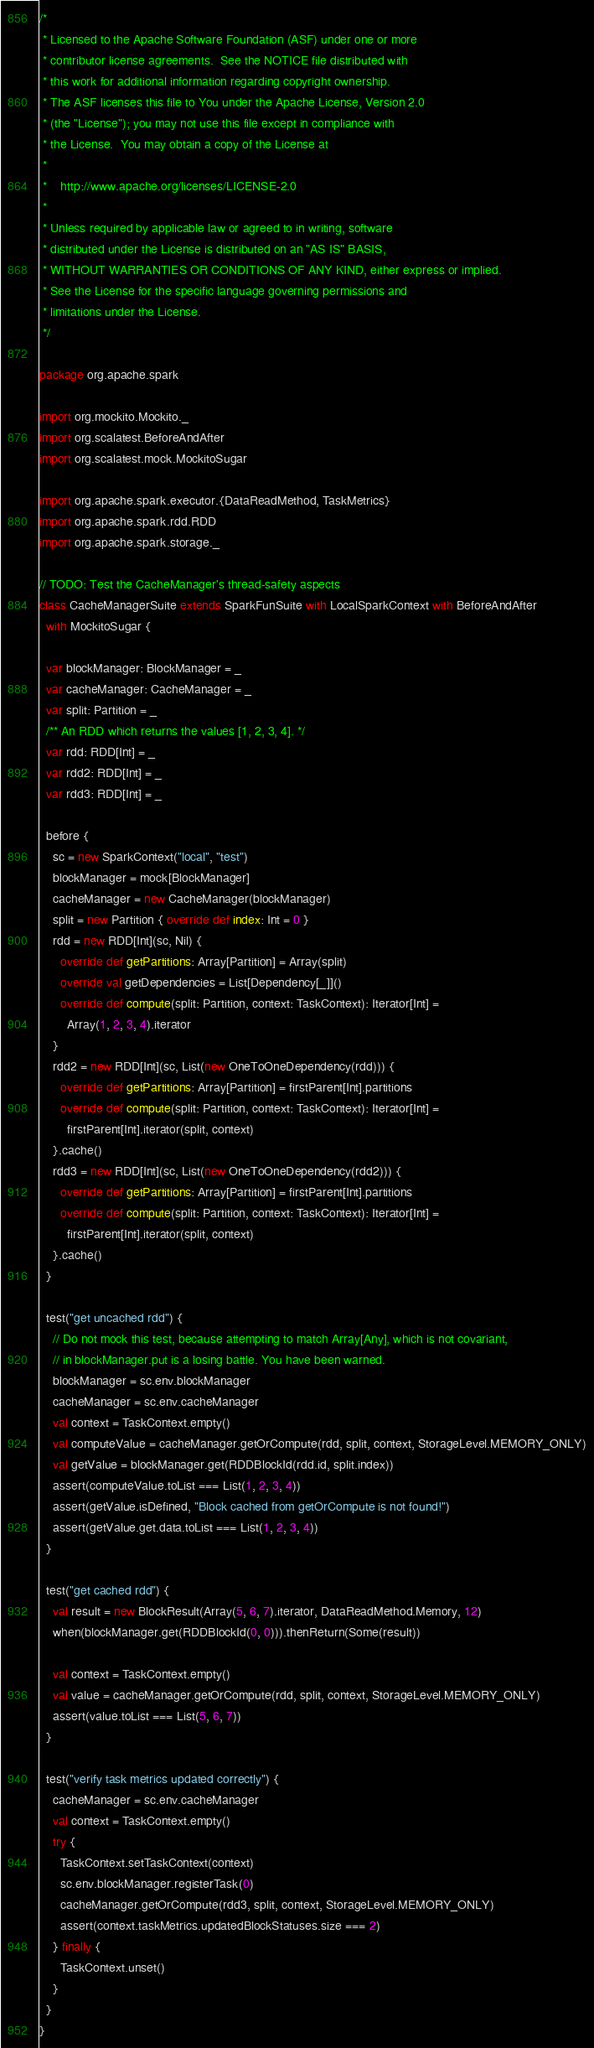<code> <loc_0><loc_0><loc_500><loc_500><_Scala_>/*
 * Licensed to the Apache Software Foundation (ASF) under one or more
 * contributor license agreements.  See the NOTICE file distributed with
 * this work for additional information regarding copyright ownership.
 * The ASF licenses this file to You under the Apache License, Version 2.0
 * (the "License"); you may not use this file except in compliance with
 * the License.  You may obtain a copy of the License at
 *
 *    http://www.apache.org/licenses/LICENSE-2.0
 *
 * Unless required by applicable law or agreed to in writing, software
 * distributed under the License is distributed on an "AS IS" BASIS,
 * WITHOUT WARRANTIES OR CONDITIONS OF ANY KIND, either express or implied.
 * See the License for the specific language governing permissions and
 * limitations under the License.
 */

package org.apache.spark

import org.mockito.Mockito._
import org.scalatest.BeforeAndAfter
import org.scalatest.mock.MockitoSugar

import org.apache.spark.executor.{DataReadMethod, TaskMetrics}
import org.apache.spark.rdd.RDD
import org.apache.spark.storage._

// TODO: Test the CacheManager's thread-safety aspects
class CacheManagerSuite extends SparkFunSuite with LocalSparkContext with BeforeAndAfter
  with MockitoSugar {

  var blockManager: BlockManager = _
  var cacheManager: CacheManager = _
  var split: Partition = _
  /** An RDD which returns the values [1, 2, 3, 4]. */
  var rdd: RDD[Int] = _
  var rdd2: RDD[Int] = _
  var rdd3: RDD[Int] = _

  before {
    sc = new SparkContext("local", "test")
    blockManager = mock[BlockManager]
    cacheManager = new CacheManager(blockManager)
    split = new Partition { override def index: Int = 0 }
    rdd = new RDD[Int](sc, Nil) {
      override def getPartitions: Array[Partition] = Array(split)
      override val getDependencies = List[Dependency[_]]()
      override def compute(split: Partition, context: TaskContext): Iterator[Int] =
        Array(1, 2, 3, 4).iterator
    }
    rdd2 = new RDD[Int](sc, List(new OneToOneDependency(rdd))) {
      override def getPartitions: Array[Partition] = firstParent[Int].partitions
      override def compute(split: Partition, context: TaskContext): Iterator[Int] =
        firstParent[Int].iterator(split, context)
    }.cache()
    rdd3 = new RDD[Int](sc, List(new OneToOneDependency(rdd2))) {
      override def getPartitions: Array[Partition] = firstParent[Int].partitions
      override def compute(split: Partition, context: TaskContext): Iterator[Int] =
        firstParent[Int].iterator(split, context)
    }.cache()
  }

  test("get uncached rdd") {
    // Do not mock this test, because attempting to match Array[Any], which is not covariant,
    // in blockManager.put is a losing battle. You have been warned.
    blockManager = sc.env.blockManager
    cacheManager = sc.env.cacheManager
    val context = TaskContext.empty()
    val computeValue = cacheManager.getOrCompute(rdd, split, context, StorageLevel.MEMORY_ONLY)
    val getValue = blockManager.get(RDDBlockId(rdd.id, split.index))
    assert(computeValue.toList === List(1, 2, 3, 4))
    assert(getValue.isDefined, "Block cached from getOrCompute is not found!")
    assert(getValue.get.data.toList === List(1, 2, 3, 4))
  }

  test("get cached rdd") {
    val result = new BlockResult(Array(5, 6, 7).iterator, DataReadMethod.Memory, 12)
    when(blockManager.get(RDDBlockId(0, 0))).thenReturn(Some(result))

    val context = TaskContext.empty()
    val value = cacheManager.getOrCompute(rdd, split, context, StorageLevel.MEMORY_ONLY)
    assert(value.toList === List(5, 6, 7))
  }

  test("verify task metrics updated correctly") {
    cacheManager = sc.env.cacheManager
    val context = TaskContext.empty()
    try {
      TaskContext.setTaskContext(context)
      sc.env.blockManager.registerTask(0)
      cacheManager.getOrCompute(rdd3, split, context, StorageLevel.MEMORY_ONLY)
      assert(context.taskMetrics.updatedBlockStatuses.size === 2)
    } finally {
      TaskContext.unset()
    }
  }
}
</code> 